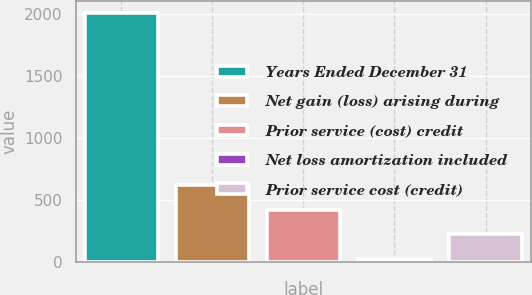<chart> <loc_0><loc_0><loc_500><loc_500><bar_chart><fcel>Years Ended December 31<fcel>Net gain (loss) arising during<fcel>Prior service (cost) credit<fcel>Net loss amortization included<fcel>Prior service cost (credit)<nl><fcel>2008<fcel>620.67<fcel>422.48<fcel>26.1<fcel>224.29<nl></chart> 